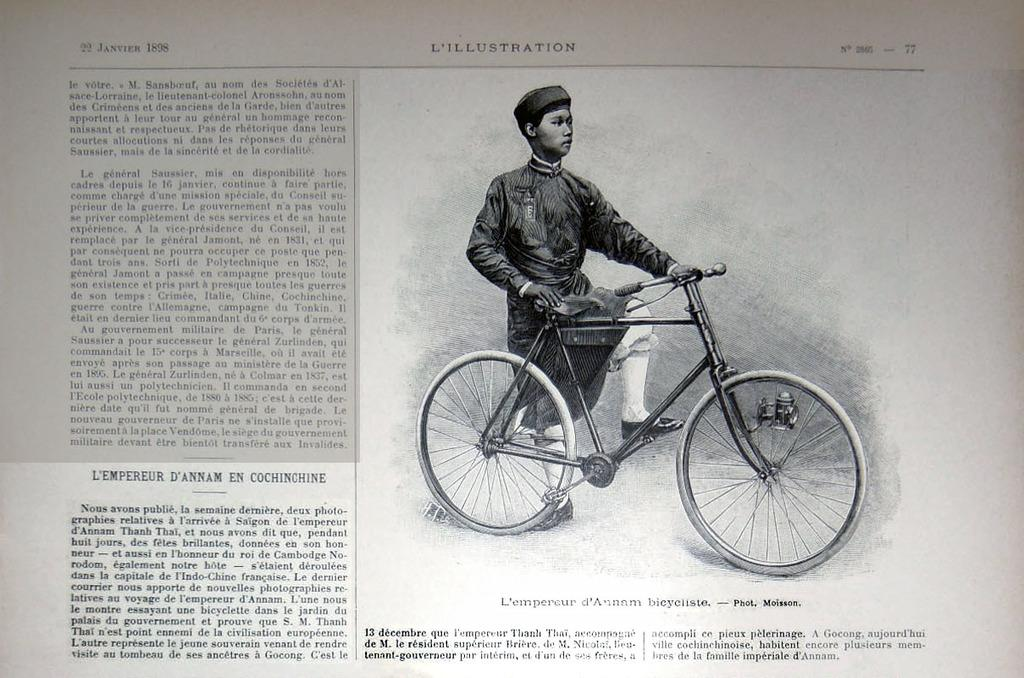What is depicted on the paper in the image? The paper contains an image of a man. What object can be seen on the ground in the image? There is a bicycle on the ground in the image. What else is present on the paper besides the image? There is text on the paper. How does the tiger contribute to the quiet atmosphere in the image? There is no tiger present in the image, so it cannot contribute to the atmosphere. 